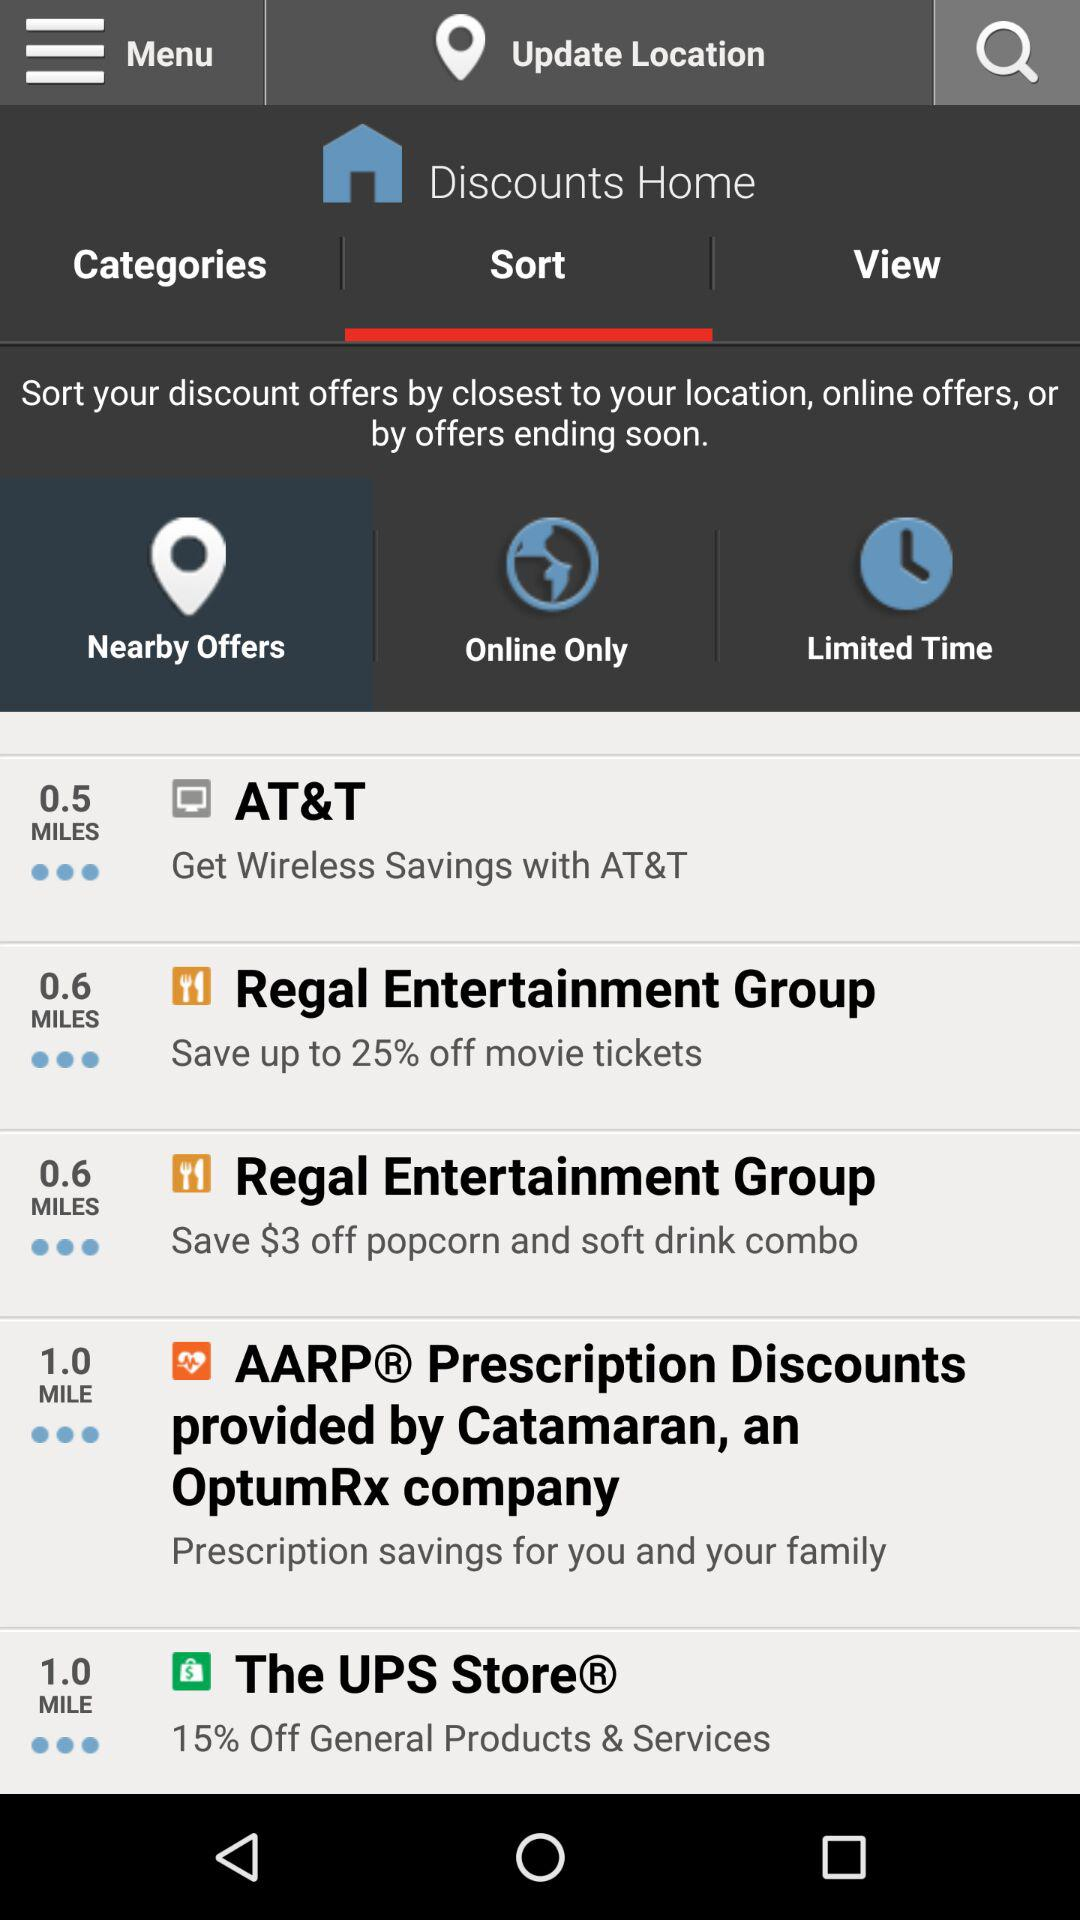Which option is selected for the "Discounts Home"? The selected option for the "Discounts Home" is "Sort". 